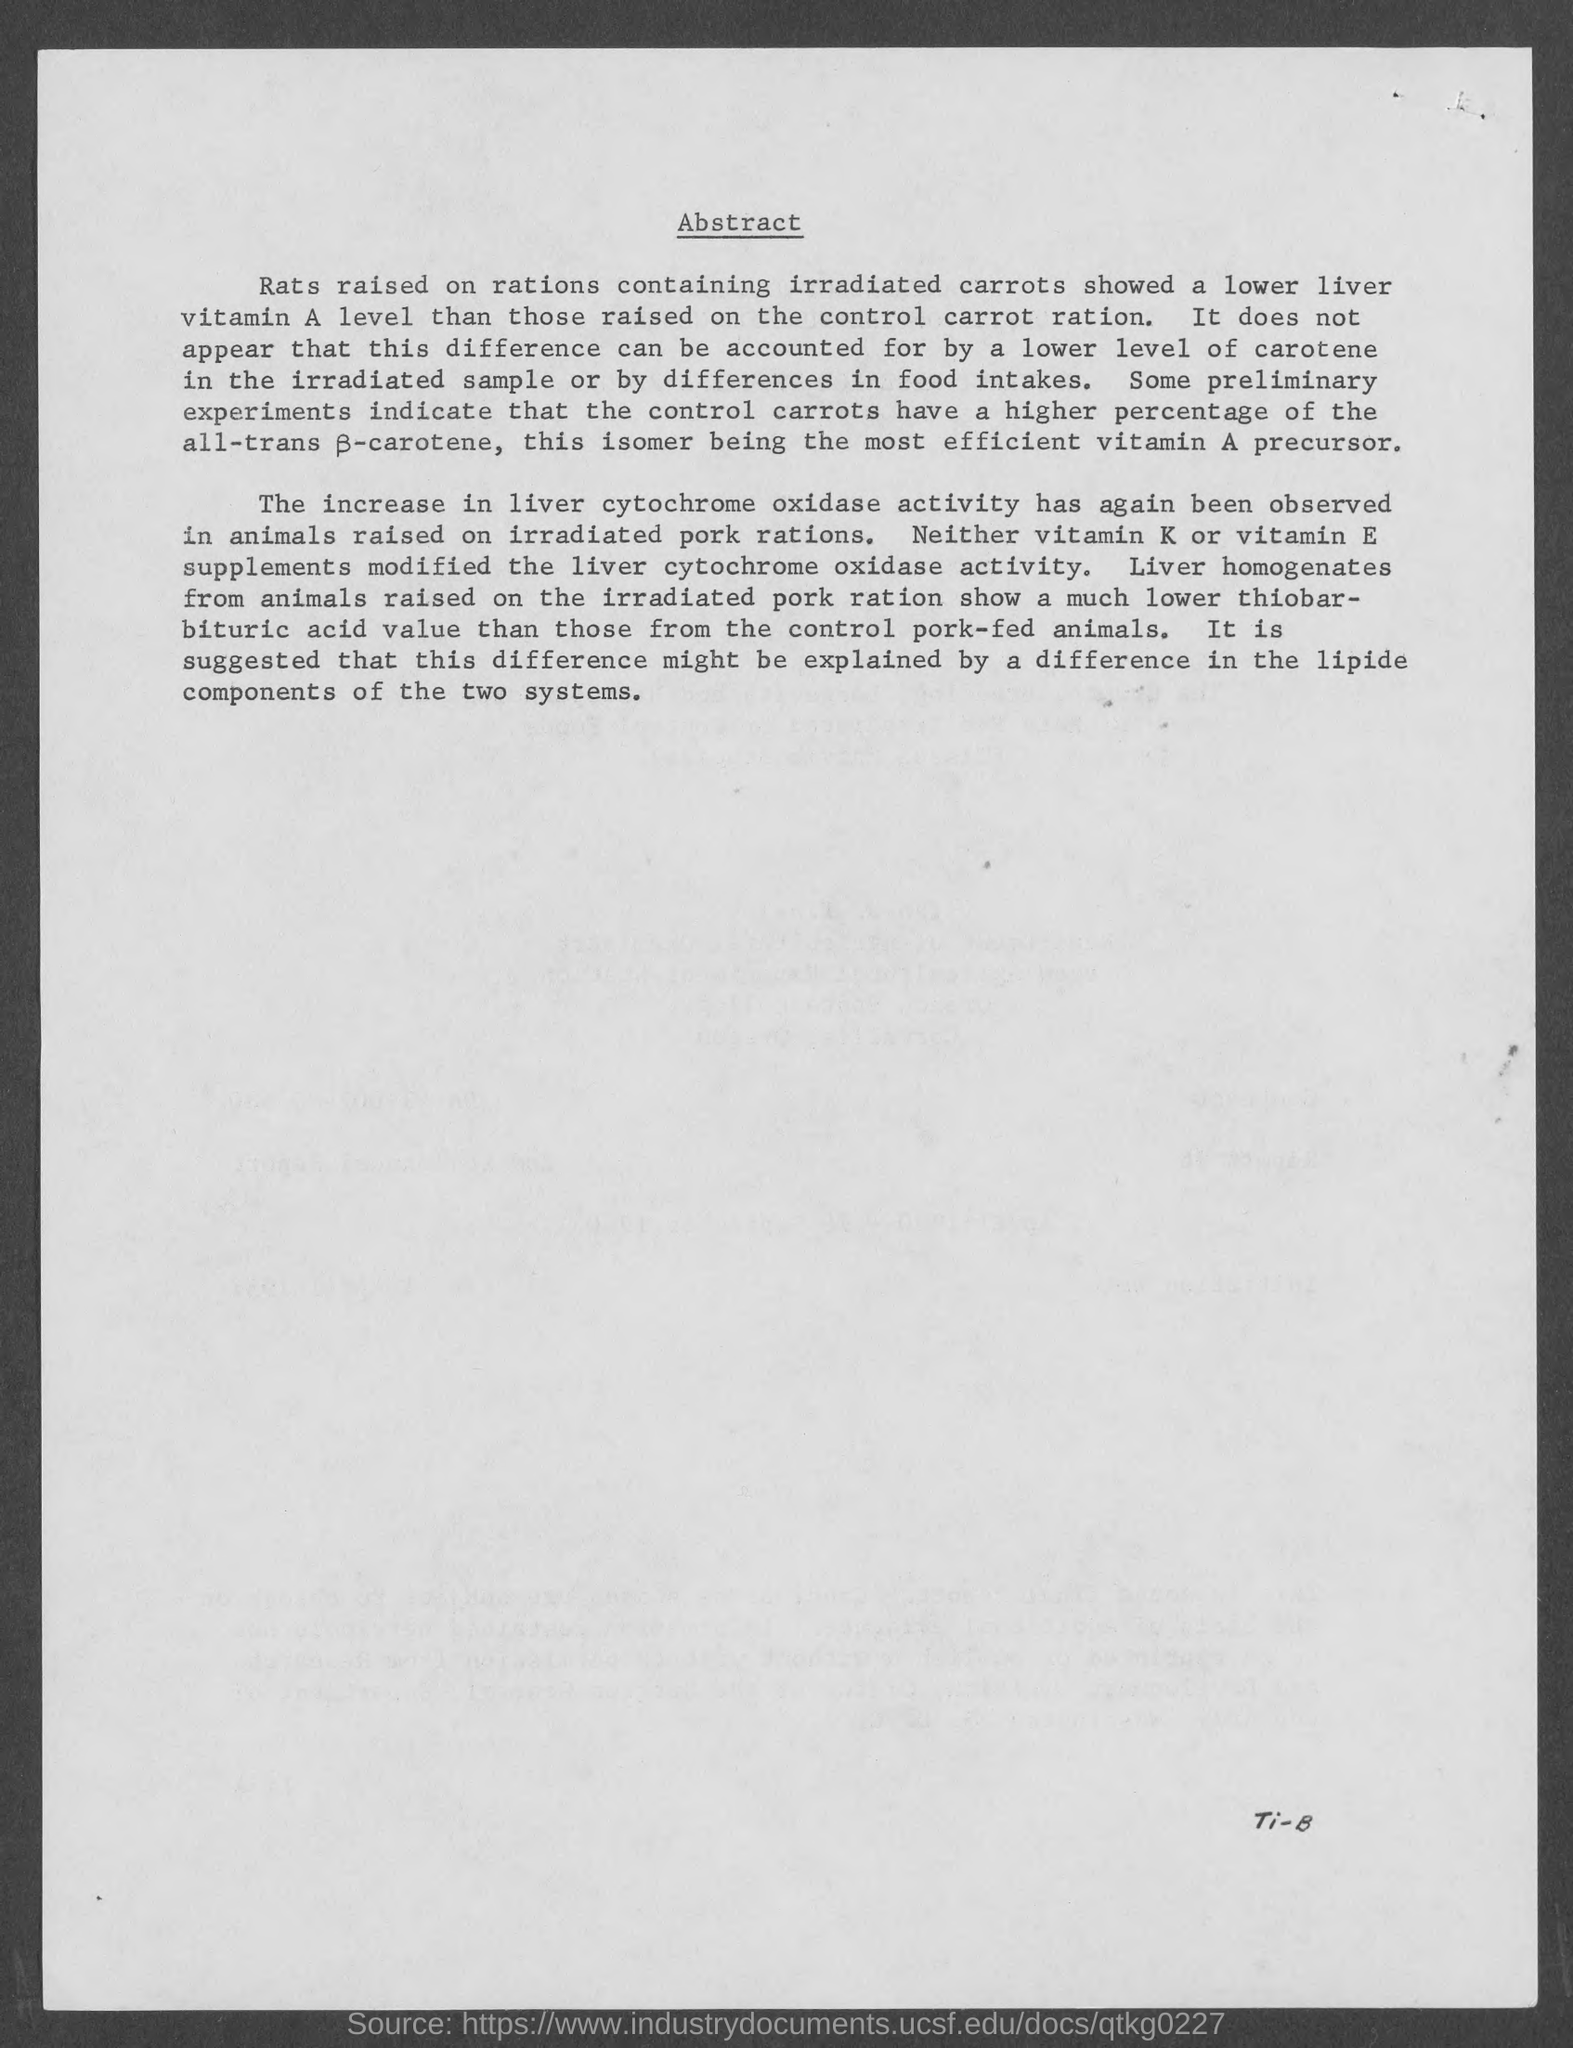Identify some key points in this picture. The heading of the page is 'Abstract'. 